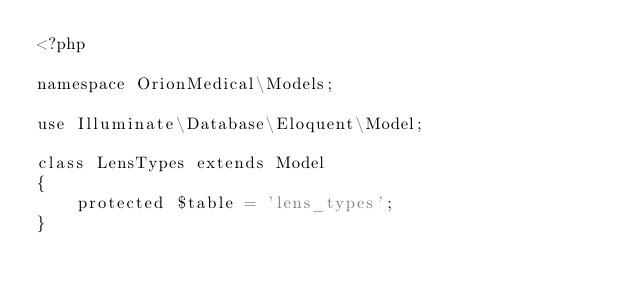<code> <loc_0><loc_0><loc_500><loc_500><_PHP_><?php

namespace OrionMedical\Models;

use Illuminate\Database\Eloquent\Model;

class LensTypes extends Model
{
    protected $table = 'lens_types';
}
</code> 